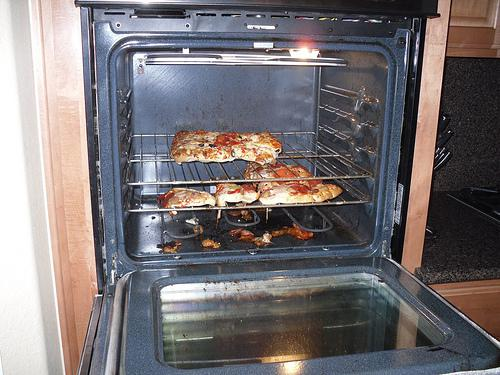Question: where is the oven?
Choices:
A. Next to fridge.
B. Kitchen.
C. Next to sink.
D. Under microwave.
Answer with the letter. Answer: B Question: what melted onto the oven bottom?
Choices:
A. Cheese.
B. Chicken grease.
C. Pizza.
D. Plastic.
Answer with the letter. Answer: A Question: when is the pizza in the oven?
Choices:
A. When its cooking.
B. When man puts it in there.
C. Now.
D. When the toppings get put on.
Answer with the letter. Answer: C Question: how many ovens are there?
Choices:
A. Two.
B. One.
C. Three.
D. Four.
Answer with the letter. Answer: B 